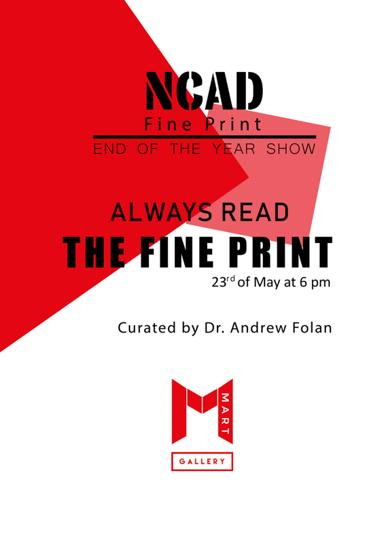What is the event mentioned in the poster?
 The event mentioned in the poster is the "End of the Year Show - Always Read the Fine Print." When is the event taking place? The event is taking place on the 23rd of May at 6 pm. Who is the curator of the event? Dr. Andrew Folan is the curator of the event. What type of show is being advertised on the poster? The show being advertised is an art exhibition, specifically focusing on fine print. Can you describe the design of the poster? The poster has a red and white color scheme, featuring text that provides the event's details. There is also an image of a man wearing a red shirt, possibly representing one of the pieces featured in the show or the artist themselves. 